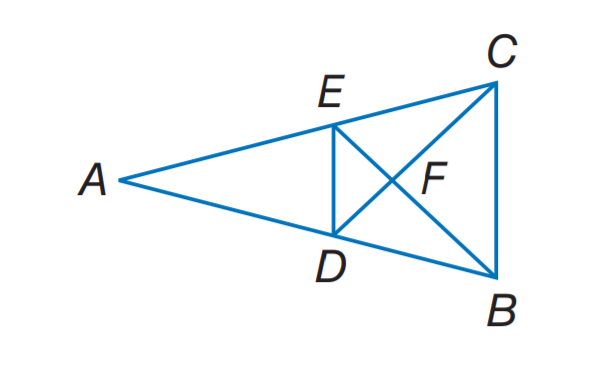Answer the mathemtical geometry problem and directly provide the correct option letter.
Question: Find the perimeter of the \triangle D E F, if \triangle D E F \sim \triangle C B F, perimeter of \triangle C B F = 27, D F = 6, F C = 8.
Choices: A: 16 B: 17.25 C: 20.25 D: 27 C 